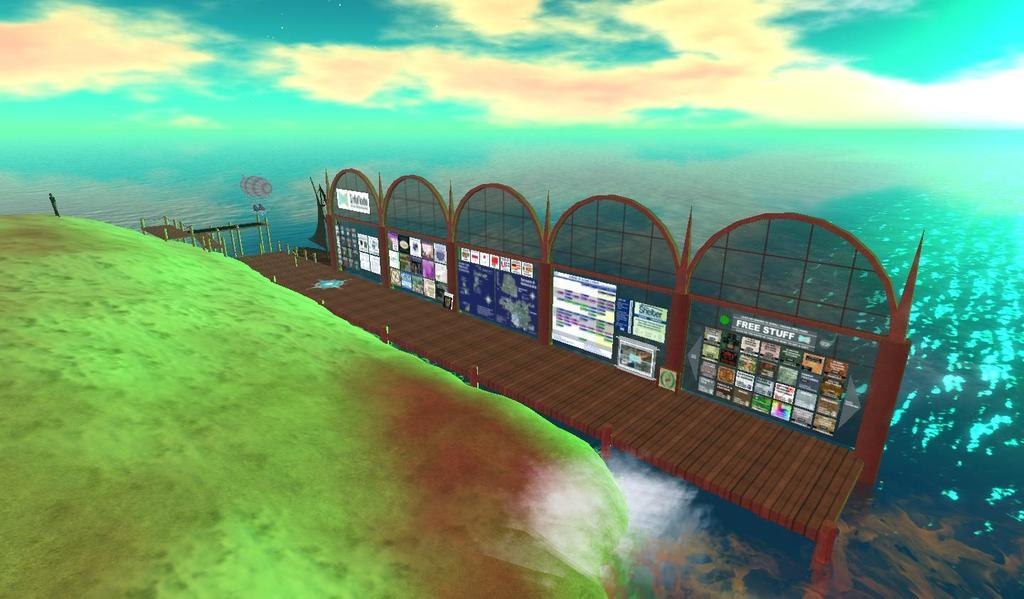What type of structure can be seen in the image? There is a bridge in the image. What is attached to a board in the image? Stickers are attached to a board in the image. What type of landscape is visible in the image? There is a green garden in the image. What natural element is visible in the image? Water is visible in the image. What colors can be seen in the background of the image? The background of the image includes green, white, and blue colors. Has the image been altered in any way? Yes, the image has been edited. How many chickens are present in the image? There are no chickens present in the image. What type of mice can be seen running on the bridge in the image? There are no mice present in the image, and the bridge is not depicted as having any rodents running on it. 